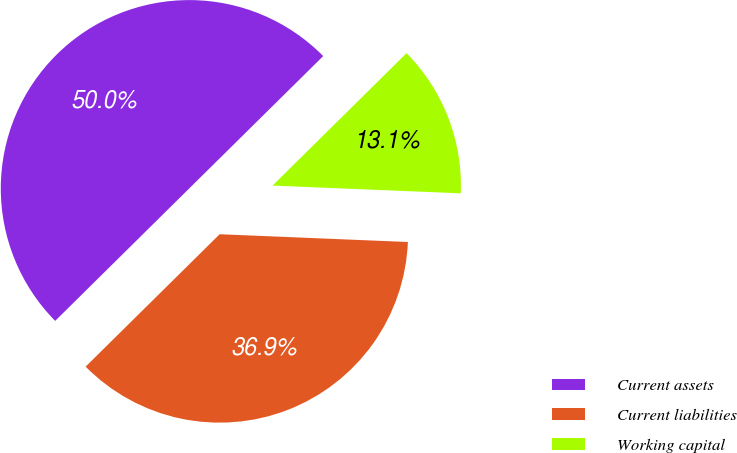Convert chart. <chart><loc_0><loc_0><loc_500><loc_500><pie_chart><fcel>Current assets<fcel>Current liabilities<fcel>Working capital<nl><fcel>50.0%<fcel>36.94%<fcel>13.06%<nl></chart> 